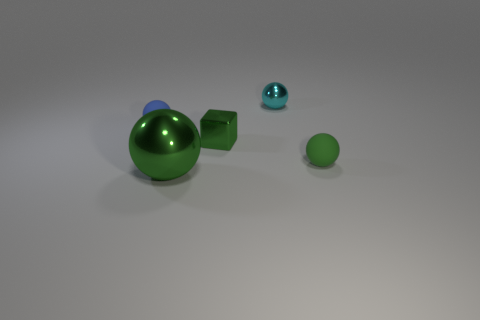What is the color of the rubber object that is on the right side of the metal sphere that is in front of the tiny rubber sphere left of the cyan sphere?
Provide a succinct answer. Green. Does the cube have the same material as the blue sphere?
Offer a very short reply. No. Is there a big metallic ball right of the green sphere that is right of the green thing in front of the tiny green sphere?
Give a very brief answer. No. Is the color of the large shiny sphere the same as the small cube?
Offer a terse response. Yes. Are there fewer tiny matte spheres than large purple cubes?
Your response must be concise. No. Is the material of the tiny sphere that is in front of the blue rubber ball the same as the small green object that is behind the green rubber sphere?
Keep it short and to the point. No. Is the number of tiny objects that are in front of the tiny green metal object less than the number of yellow things?
Ensure brevity in your answer.  No. What number of tiny green things are left of the small metal thing that is right of the tiny shiny cube?
Your response must be concise. 1. How big is the object that is both behind the tiny green metal cube and left of the small shiny sphere?
Your answer should be compact. Small. Are there any other things that have the same material as the blue object?
Keep it short and to the point. Yes. 